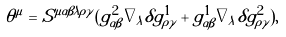Convert formula to latex. <formula><loc_0><loc_0><loc_500><loc_500>\theta ^ { \mu } = S ^ { \mu \alpha \beta \lambda \rho \gamma } ( g ^ { 2 } _ { \alpha \beta } \nabla _ { \lambda } \delta g ^ { 1 } _ { \rho \gamma } + g ^ { 1 } _ { \alpha \beta } \nabla _ { \lambda } \delta g ^ { 2 } _ { \rho \gamma } ) ,</formula> 